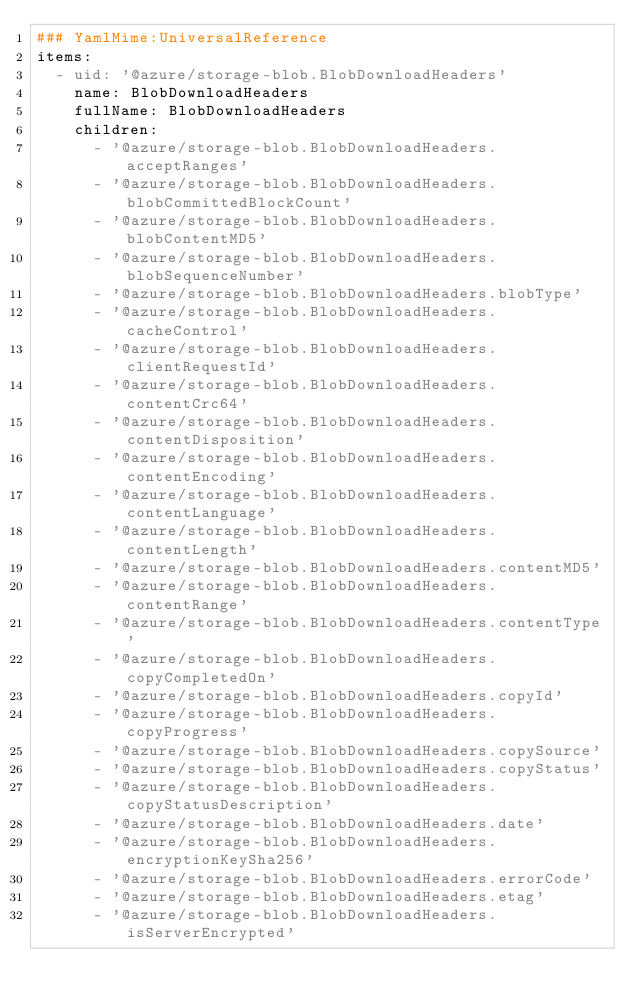Convert code to text. <code><loc_0><loc_0><loc_500><loc_500><_YAML_>### YamlMime:UniversalReference
items:
  - uid: '@azure/storage-blob.BlobDownloadHeaders'
    name: BlobDownloadHeaders
    fullName: BlobDownloadHeaders
    children:
      - '@azure/storage-blob.BlobDownloadHeaders.acceptRanges'
      - '@azure/storage-blob.BlobDownloadHeaders.blobCommittedBlockCount'
      - '@azure/storage-blob.BlobDownloadHeaders.blobContentMD5'
      - '@azure/storage-blob.BlobDownloadHeaders.blobSequenceNumber'
      - '@azure/storage-blob.BlobDownloadHeaders.blobType'
      - '@azure/storage-blob.BlobDownloadHeaders.cacheControl'
      - '@azure/storage-blob.BlobDownloadHeaders.clientRequestId'
      - '@azure/storage-blob.BlobDownloadHeaders.contentCrc64'
      - '@azure/storage-blob.BlobDownloadHeaders.contentDisposition'
      - '@azure/storage-blob.BlobDownloadHeaders.contentEncoding'
      - '@azure/storage-blob.BlobDownloadHeaders.contentLanguage'
      - '@azure/storage-blob.BlobDownloadHeaders.contentLength'
      - '@azure/storage-blob.BlobDownloadHeaders.contentMD5'
      - '@azure/storage-blob.BlobDownloadHeaders.contentRange'
      - '@azure/storage-blob.BlobDownloadHeaders.contentType'
      - '@azure/storage-blob.BlobDownloadHeaders.copyCompletedOn'
      - '@azure/storage-blob.BlobDownloadHeaders.copyId'
      - '@azure/storage-blob.BlobDownloadHeaders.copyProgress'
      - '@azure/storage-blob.BlobDownloadHeaders.copySource'
      - '@azure/storage-blob.BlobDownloadHeaders.copyStatus'
      - '@azure/storage-blob.BlobDownloadHeaders.copyStatusDescription'
      - '@azure/storage-blob.BlobDownloadHeaders.date'
      - '@azure/storage-blob.BlobDownloadHeaders.encryptionKeySha256'
      - '@azure/storage-blob.BlobDownloadHeaders.errorCode'
      - '@azure/storage-blob.BlobDownloadHeaders.etag'
      - '@azure/storage-blob.BlobDownloadHeaders.isServerEncrypted'</code> 